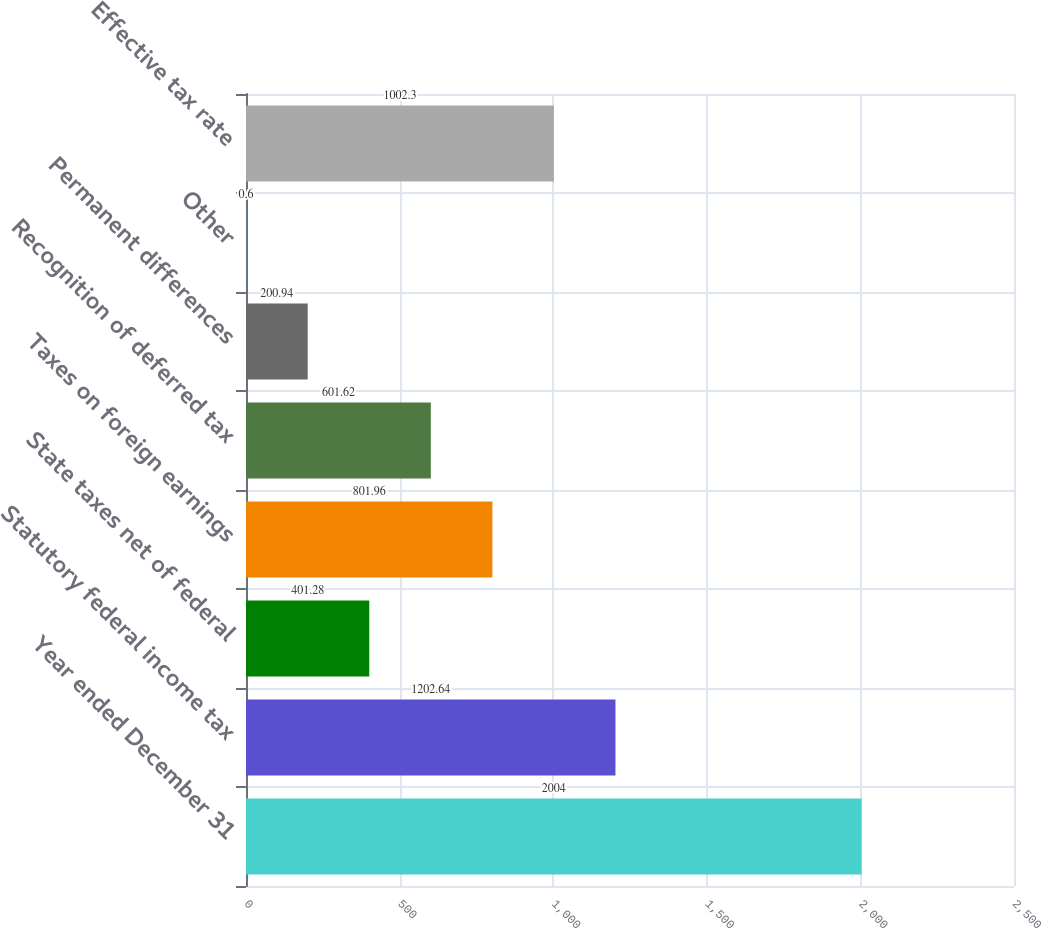Convert chart. <chart><loc_0><loc_0><loc_500><loc_500><bar_chart><fcel>Year ended December 31<fcel>Statutory federal income tax<fcel>State taxes net of federal<fcel>Taxes on foreign earnings<fcel>Recognition of deferred tax<fcel>Permanent differences<fcel>Other<fcel>Effective tax rate<nl><fcel>2004<fcel>1202.64<fcel>401.28<fcel>801.96<fcel>601.62<fcel>200.94<fcel>0.6<fcel>1002.3<nl></chart> 